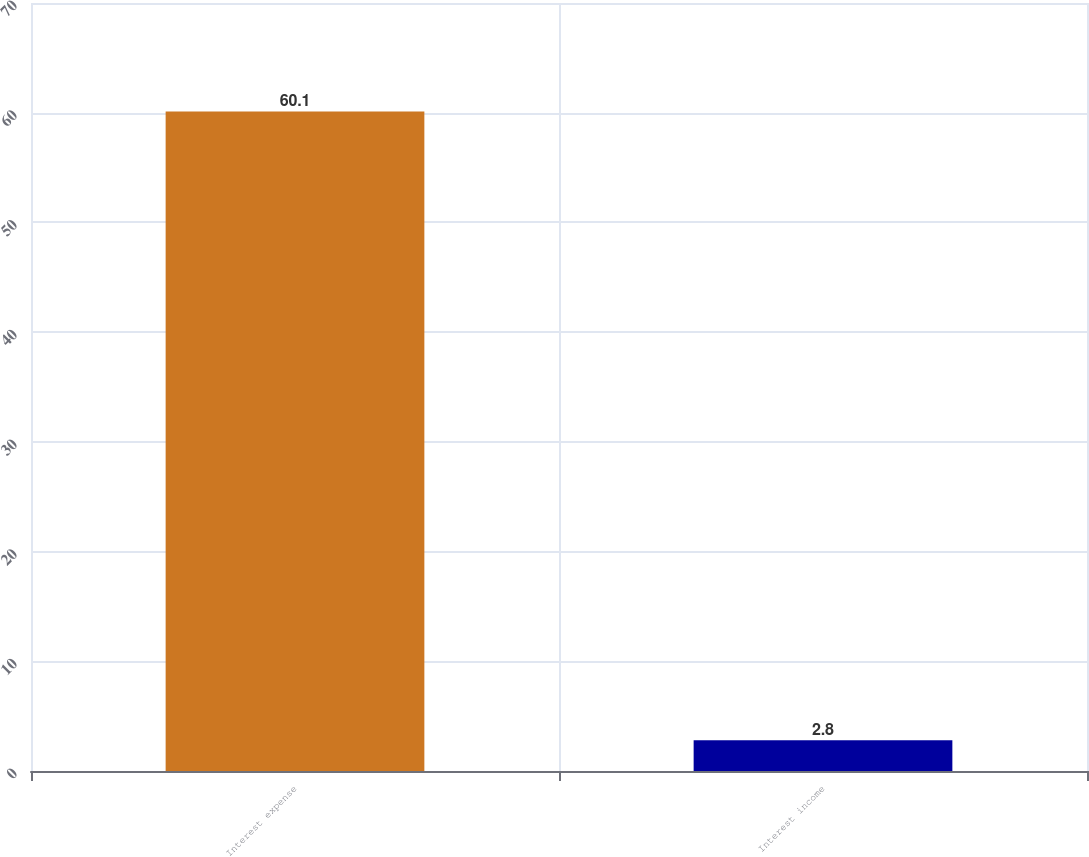Convert chart to OTSL. <chart><loc_0><loc_0><loc_500><loc_500><bar_chart><fcel>Interest expense<fcel>Interest income<nl><fcel>60.1<fcel>2.8<nl></chart> 